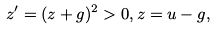<formula> <loc_0><loc_0><loc_500><loc_500>z ^ { \prime } = ( z + g ) ^ { 2 } > 0 , z = u - g ,</formula> 